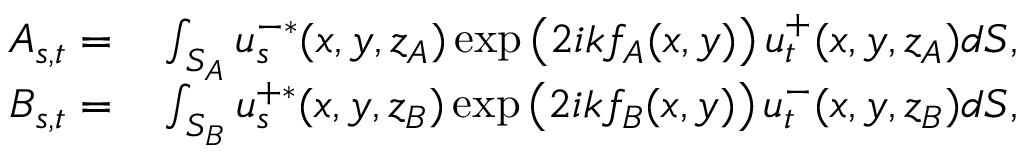Convert formula to latex. <formula><loc_0><loc_0><loc_500><loc_500>\begin{array} { r l } { A _ { s , t } = } & \int _ { S _ { A } } u _ { s } ^ { - * } ( x , y , z _ { A } ) \exp \left ( 2 i k f _ { A } ( x , y ) \right ) u _ { t } ^ { + } ( x , y , z _ { A } ) d S , } \\ { B _ { s , t } = } & \int _ { S _ { B } } u _ { s } ^ { + * } ( x , y , z _ { B } ) \exp \left ( 2 i k f _ { B } ( x , y ) \right ) u _ { t } ^ { - } ( x , y , z _ { B } ) d S , } \end{array}</formula> 